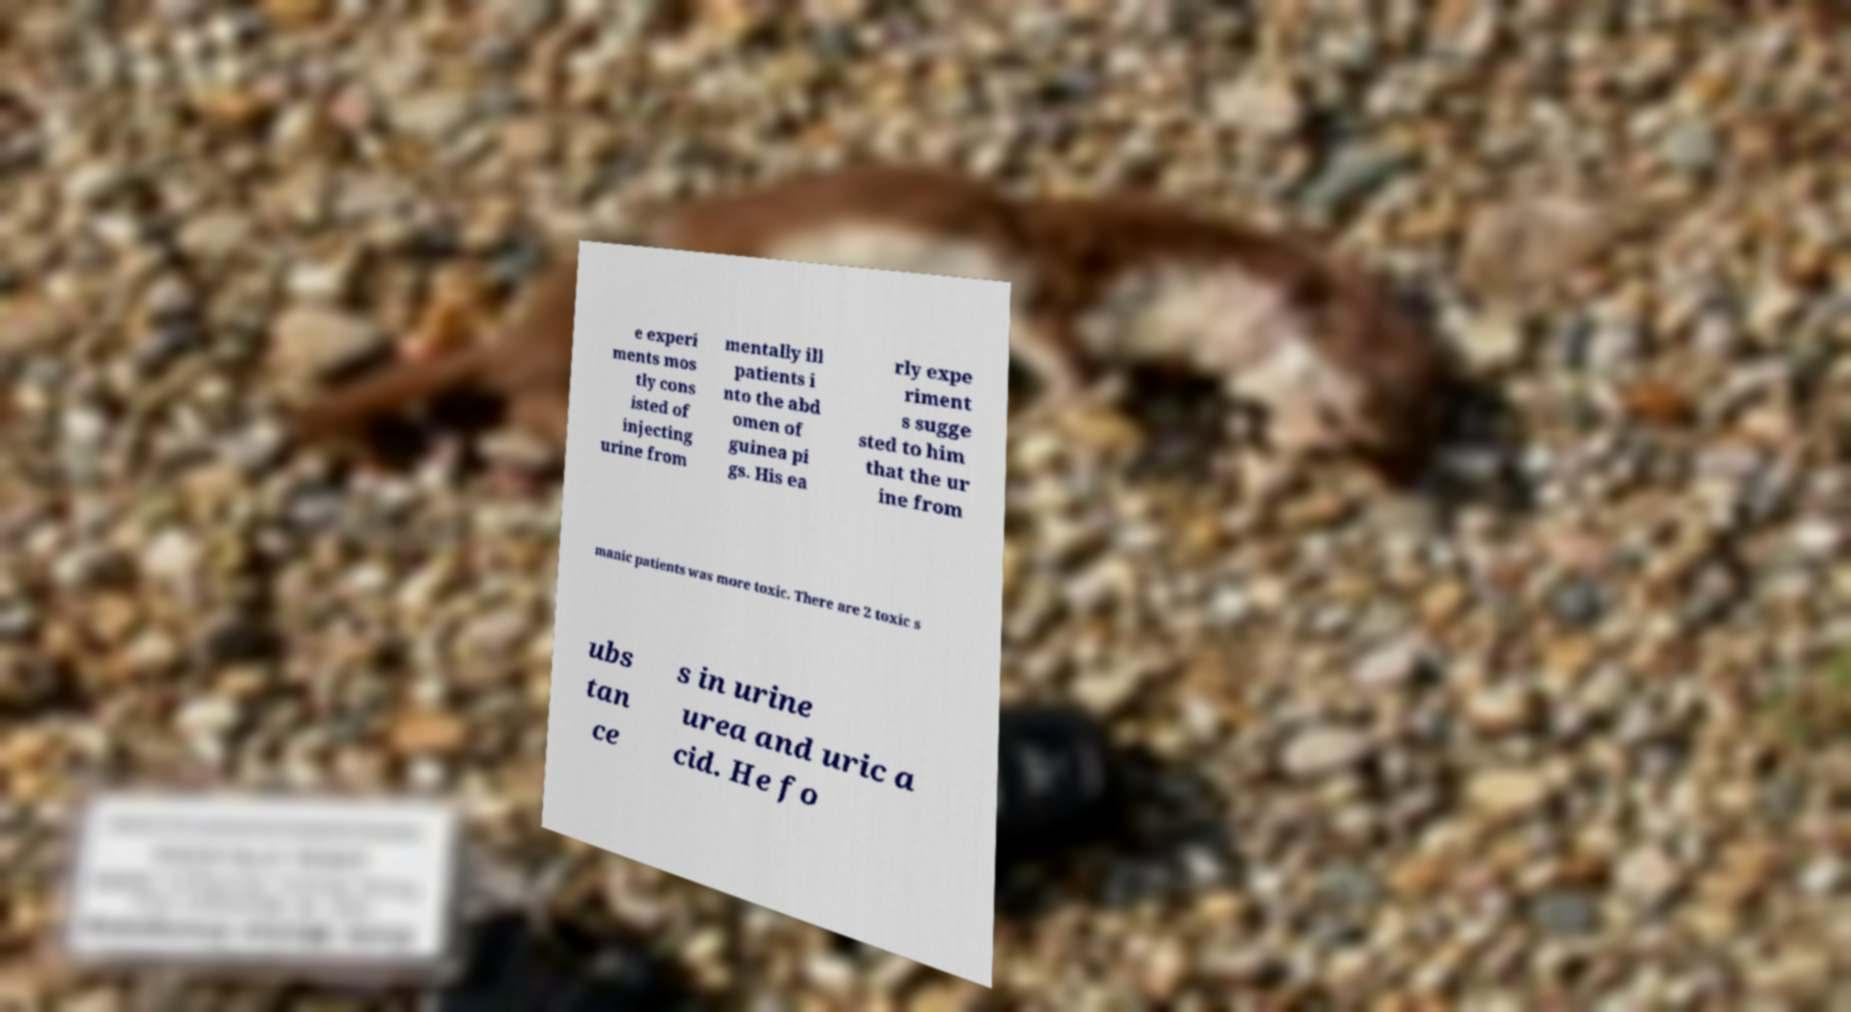Can you read and provide the text displayed in the image?This photo seems to have some interesting text. Can you extract and type it out for me? e experi ments mos tly cons isted of injecting urine from mentally ill patients i nto the abd omen of guinea pi gs. His ea rly expe riment s sugge sted to him that the ur ine from manic patients was more toxic. There are 2 toxic s ubs tan ce s in urine urea and uric a cid. He fo 